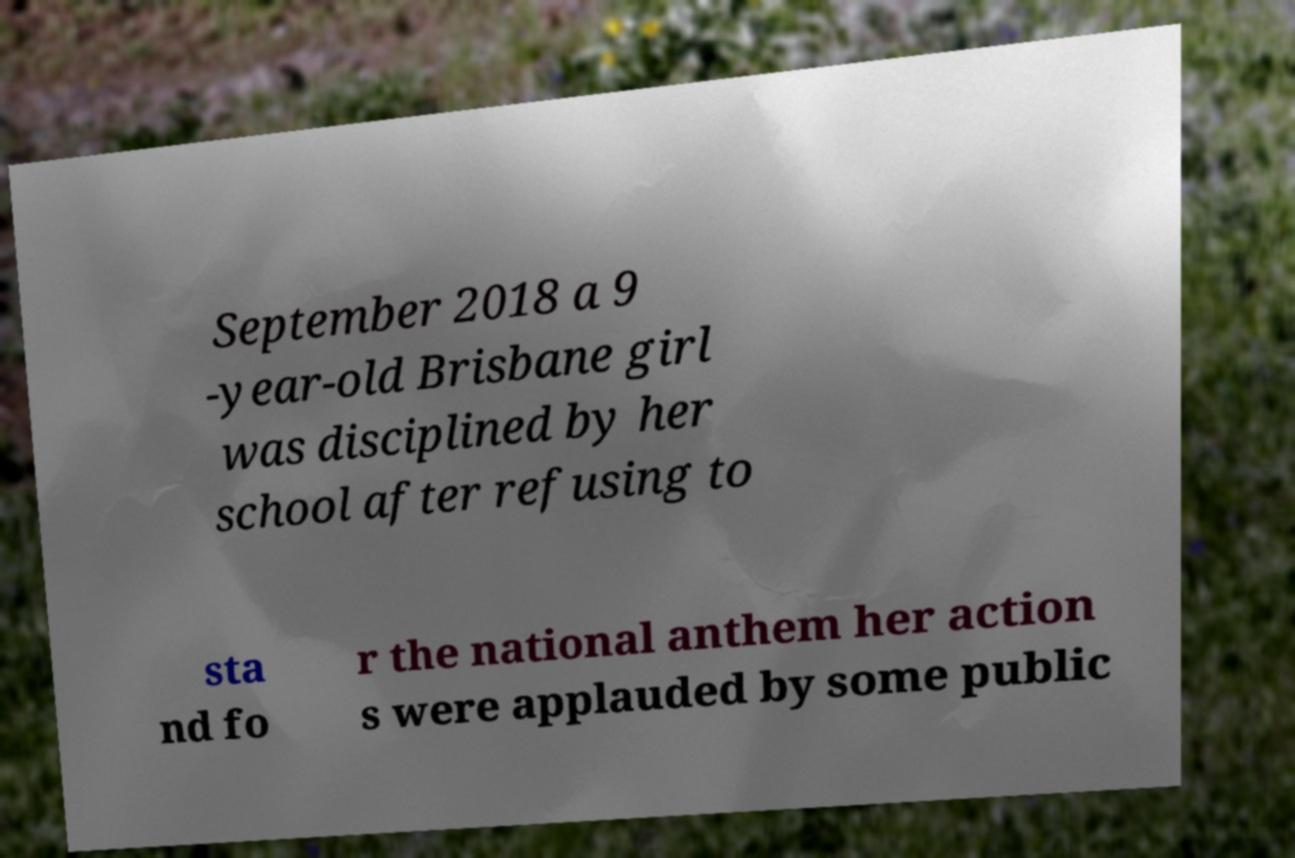I need the written content from this picture converted into text. Can you do that? September 2018 a 9 -year-old Brisbane girl was disciplined by her school after refusing to sta nd fo r the national anthem her action s were applauded by some public 